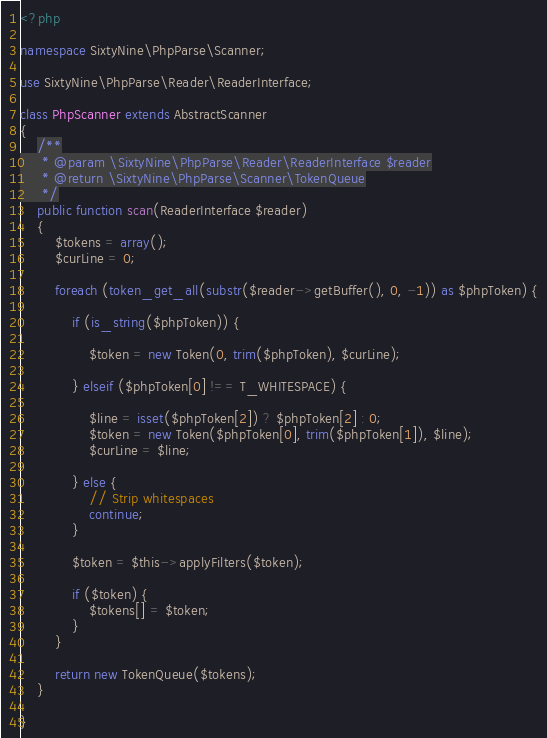<code> <loc_0><loc_0><loc_500><loc_500><_PHP_><?php

namespace SixtyNine\PhpParse\Scanner;

use SixtyNine\PhpParse\Reader\ReaderInterface;

class PhpScanner extends AbstractScanner
{
    /**
     * @param \SixtyNine\PhpParse\Reader\ReaderInterface $reader
     * @return \SixtyNine\PhpParse\Scanner\TokenQueue
     */
    public function scan(ReaderInterface $reader)
    {
        $tokens = array();
        $curLine = 0;

        foreach (token_get_all(substr($reader->getBuffer(), 0, -1)) as $phpToken) {
            
            if (is_string($phpToken)) {

                $token = new Token(0, trim($phpToken), $curLine);

            } elseif ($phpToken[0] !== T_WHITESPACE) {

                $line = isset($phpToken[2]) ? $phpToken[2] : 0;
                $token = new Token($phpToken[0], trim($phpToken[1]), $line);
                $curLine = $line;

            } else {
                // Strip whitespaces
                continue;
            }

            $token = $this->applyFilters($token);

            if ($token) {
                $tokens[] = $token;
            }
        }

        return new TokenQueue($tokens);
    }

}
</code> 